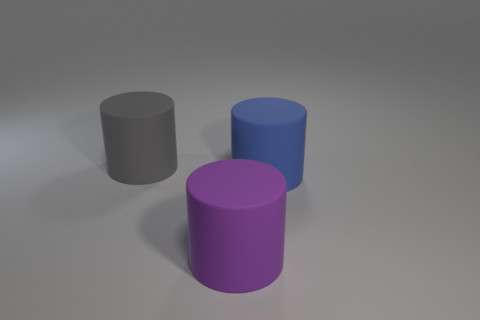Add 2 big brown rubber cubes. How many objects exist? 5 Add 3 big yellow metallic objects. How many big yellow metallic objects exist? 3 Subtract 0 blue spheres. How many objects are left? 3 Subtract all big brown cubes. Subtract all blue things. How many objects are left? 2 Add 2 matte cylinders. How many matte cylinders are left? 5 